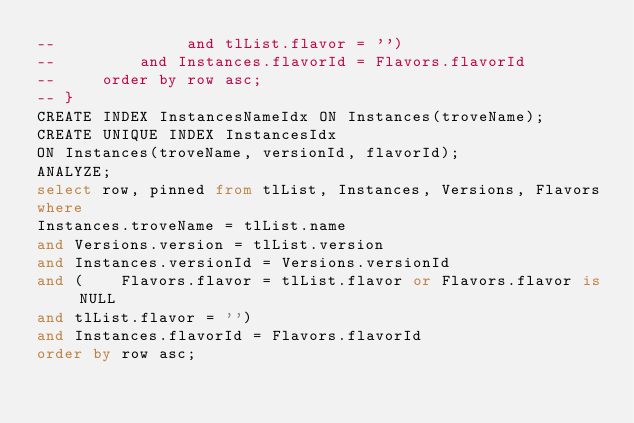<code> <loc_0><loc_0><loc_500><loc_500><_SQL_>--              and tlList.flavor = '')
--         and Instances.flavorId = Flavors.flavorId
--     order by row asc;
-- }
CREATE INDEX InstancesNameIdx ON Instances(troveName);
CREATE UNIQUE INDEX InstancesIdx 
ON Instances(troveName, versionId, flavorId);
ANALYZE;
select row, pinned from tlList, Instances, Versions, Flavors
where
Instances.troveName = tlList.name
and Versions.version = tlList.version
and Instances.versionId = Versions.versionId
and (    Flavors.flavor = tlList.flavor or Flavors.flavor is NULL
and tlList.flavor = '')
and Instances.flavorId = Flavors.flavorId
order by row asc;</code> 